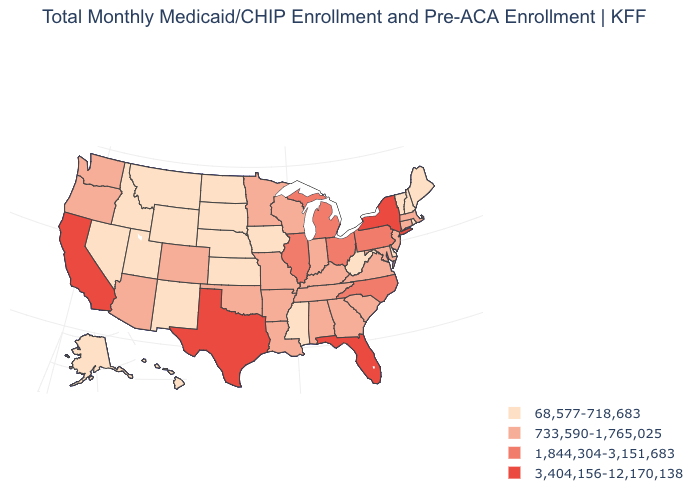Does Alaska have the lowest value in the West?
Concise answer only. Yes. What is the lowest value in the MidWest?
Give a very brief answer. 68,577-718,683. What is the lowest value in states that border New Jersey?
Answer briefly. 68,577-718,683. What is the highest value in the USA?
Short answer required. 3,404,156-12,170,138. Name the states that have a value in the range 733,590-1,765,025?
Answer briefly. Alabama, Arizona, Arkansas, Colorado, Connecticut, Georgia, Indiana, Kentucky, Louisiana, Maryland, Massachusetts, Minnesota, Missouri, New Jersey, Oklahoma, Oregon, South Carolina, Tennessee, Virginia, Washington, Wisconsin. What is the value of Florida?
Write a very short answer. 3,404,156-12,170,138. What is the value of Massachusetts?
Keep it brief. 733,590-1,765,025. What is the value of Idaho?
Write a very short answer. 68,577-718,683. Among the states that border Michigan , does Ohio have the highest value?
Keep it brief. Yes. Among the states that border Arkansas , which have the lowest value?
Concise answer only. Mississippi. What is the lowest value in the USA?
Give a very brief answer. 68,577-718,683. Does Montana have the same value as Alabama?
Give a very brief answer. No. Name the states that have a value in the range 1,844,304-3,151,683?
Keep it brief. Illinois, Michigan, North Carolina, Ohio, Pennsylvania. Is the legend a continuous bar?
Concise answer only. No. 